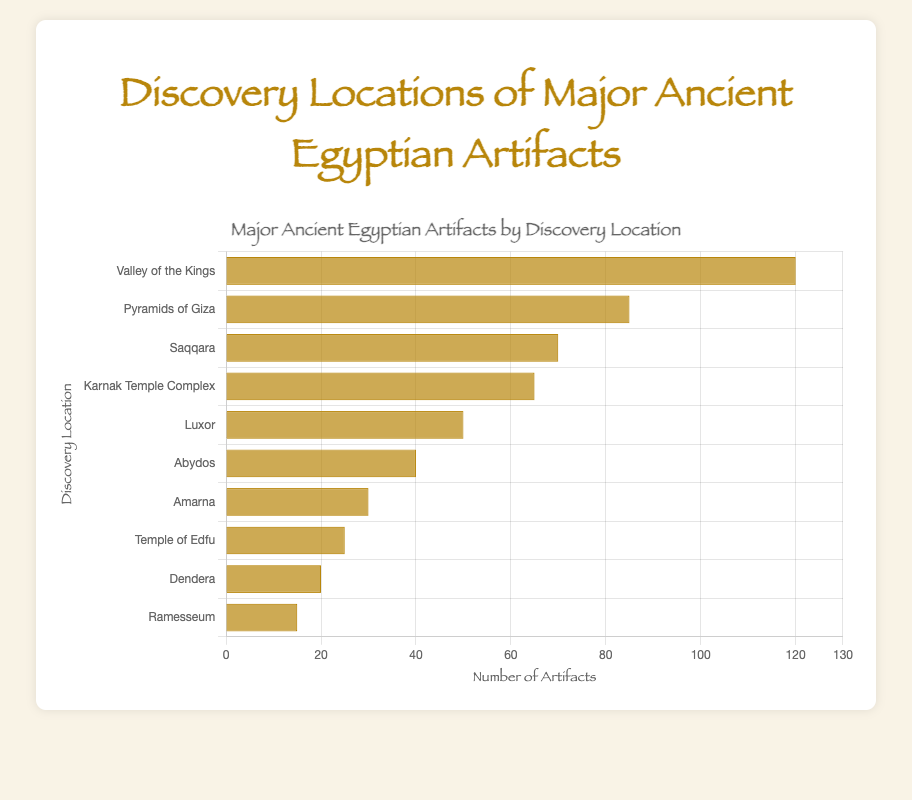Which location has the highest number of artifacts discovered? By examining the lengths of the bars, the "Valley of the Kings" has the longest bar, indicating it has the highest number of artifacts discovered.
Answer: Valley of the Kings Which location has more artifacts discovered, Pyramids of Giza or Saqqara? By comparing the lengths of the two bars, the bar for "Pyramids of Giza" is longer than that for "Saqqara". Hence, more artifacts were discovered in the Pyramids of Giza.
Answer: Pyramids of Giza What is the combined total of artifacts discovered in Luxor and Abydos? Referencing the bars for "Luxor" and "Abydos," which are 50 and 40 respectively, the combined total is 50 + 40 = 90 artifacts.
Answer: 90 Between the Karnak Temple Complex and the Temple of Edfu, which location has fewer artifacts discovered? Comparing the lengths of the two bars, the bar for "Temple of Edfu" is shorter than that for "Karnak Temple Complex." Therefore, the Temple of Edfu has fewer artifacts discovered.
Answer: Temple of Edfu How many more artifacts were discovered in the Valley of the Kings than in Ramesseum? The bar for "Valley of the Kings" shows 120 artifacts, and the bar for "Ramesseum" shows 15. The difference is 120 - 15 = 105 artifacts.
Answer: 105 What is the average number of artifacts discovered across all locations? Sum all the artifacts discovered: 120 + 85 + 70 + 65 + 50 + 40 + 30 + 25 + 20 + 15 = 520. There are 10 locations, so the average is 520 / 10 = 52 artifacts.
Answer: 52 Which location shows the least number of artifacts discovered, and what is that number? By identifying the shortest bar in the chart, "Ramesseum" has the shortest, indicating it has the least artifacts discovered, which is 15.
Answer: Ramesseum, 15 How many locations have discovered more than 50 artifacts? Count the number of bars that extend beyond 50 on the x-axis. These locations are "Valley of the Kings," "Pyramids of Giza," "Saqqara," and "Karnak Temple Complex," making a total of 4 locations.
Answer: 4 